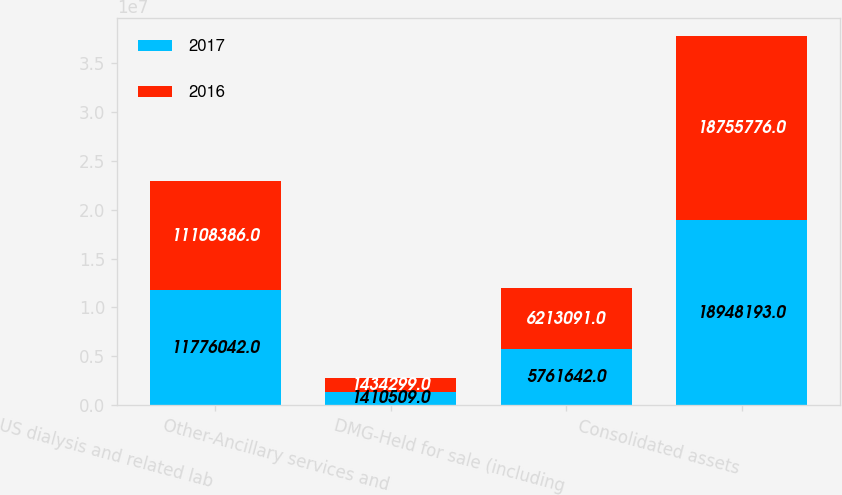<chart> <loc_0><loc_0><loc_500><loc_500><stacked_bar_chart><ecel><fcel>US dialysis and related lab<fcel>Other-Ancillary services and<fcel>DMG-Held for sale (including<fcel>Consolidated assets<nl><fcel>2017<fcel>1.1776e+07<fcel>1.41051e+06<fcel>5.76164e+06<fcel>1.89482e+07<nl><fcel>2016<fcel>1.11084e+07<fcel>1.4343e+06<fcel>6.21309e+06<fcel>1.87558e+07<nl></chart> 